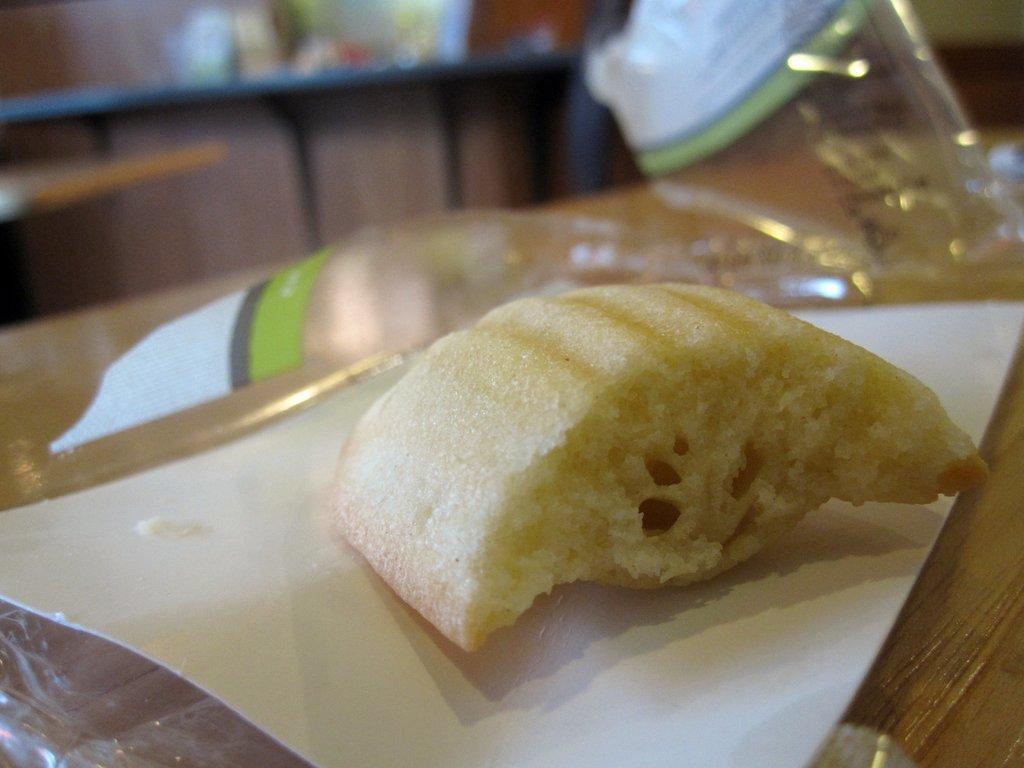Describe this image in one or two sentences. In this image we can see some food on a paper which is placed on the wooden surface. We can also see some covers beside it. On the backside we can see a wall and a table containing some objects on it. 